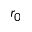Convert formula to latex. <formula><loc_0><loc_0><loc_500><loc_500>r _ { 0 }</formula> 